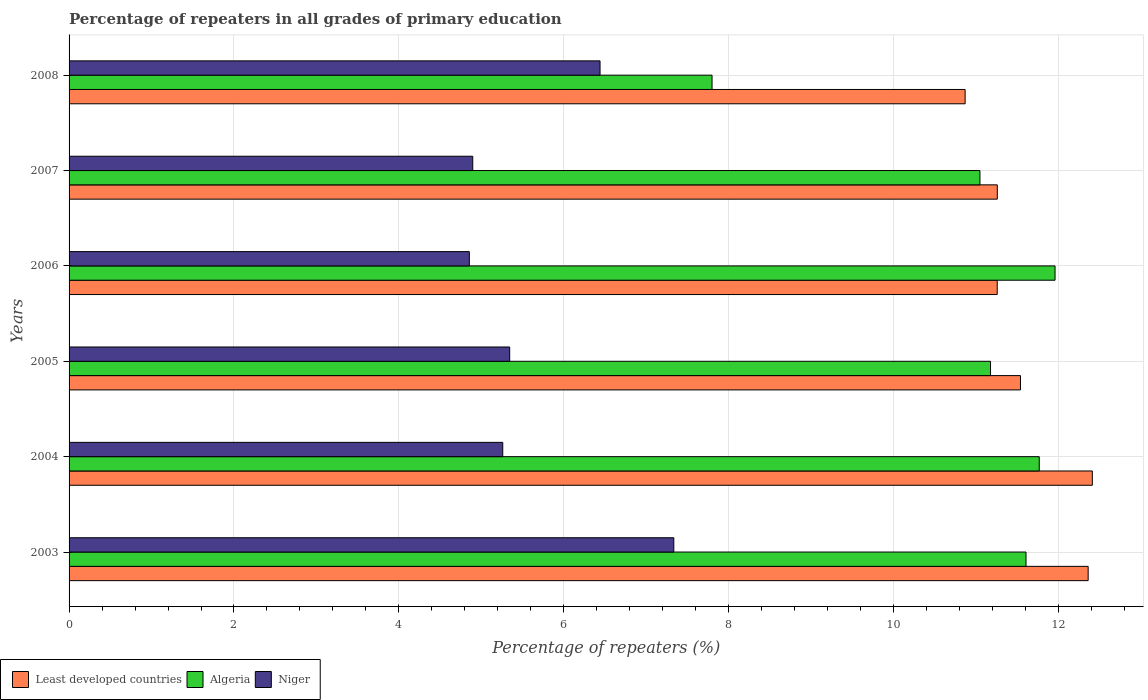How many different coloured bars are there?
Provide a succinct answer. 3. How many groups of bars are there?
Your response must be concise. 6. Are the number of bars per tick equal to the number of legend labels?
Offer a very short reply. Yes. Are the number of bars on each tick of the Y-axis equal?
Your answer should be compact. Yes. How many bars are there on the 1st tick from the bottom?
Make the answer very short. 3. In how many cases, is the number of bars for a given year not equal to the number of legend labels?
Keep it short and to the point. 0. What is the percentage of repeaters in Niger in 2007?
Offer a terse response. 4.9. Across all years, what is the maximum percentage of repeaters in Least developed countries?
Offer a very short reply. 12.41. Across all years, what is the minimum percentage of repeaters in Algeria?
Provide a short and direct response. 7.8. In which year was the percentage of repeaters in Niger maximum?
Offer a terse response. 2003. In which year was the percentage of repeaters in Niger minimum?
Make the answer very short. 2006. What is the total percentage of repeaters in Niger in the graph?
Your response must be concise. 34.13. What is the difference between the percentage of repeaters in Least developed countries in 2007 and that in 2008?
Ensure brevity in your answer.  0.39. What is the difference between the percentage of repeaters in Least developed countries in 2006 and the percentage of repeaters in Niger in 2007?
Provide a short and direct response. 6.36. What is the average percentage of repeaters in Niger per year?
Offer a very short reply. 5.69. In the year 2005, what is the difference between the percentage of repeaters in Least developed countries and percentage of repeaters in Algeria?
Ensure brevity in your answer.  0.36. What is the ratio of the percentage of repeaters in Least developed countries in 2004 to that in 2007?
Offer a very short reply. 1.1. Is the difference between the percentage of repeaters in Least developed countries in 2003 and 2008 greater than the difference between the percentage of repeaters in Algeria in 2003 and 2008?
Offer a terse response. No. What is the difference between the highest and the second highest percentage of repeaters in Least developed countries?
Your answer should be compact. 0.05. What is the difference between the highest and the lowest percentage of repeaters in Least developed countries?
Keep it short and to the point. 1.54. In how many years, is the percentage of repeaters in Least developed countries greater than the average percentage of repeaters in Least developed countries taken over all years?
Your answer should be compact. 2. What does the 2nd bar from the top in 2004 represents?
Give a very brief answer. Algeria. What does the 1st bar from the bottom in 2008 represents?
Give a very brief answer. Least developed countries. Is it the case that in every year, the sum of the percentage of repeaters in Least developed countries and percentage of repeaters in Niger is greater than the percentage of repeaters in Algeria?
Provide a short and direct response. Yes. How many bars are there?
Offer a terse response. 18. Are all the bars in the graph horizontal?
Offer a very short reply. Yes. How many years are there in the graph?
Your answer should be compact. 6. Are the values on the major ticks of X-axis written in scientific E-notation?
Offer a terse response. No. Does the graph contain any zero values?
Your answer should be very brief. No. How many legend labels are there?
Offer a very short reply. 3. What is the title of the graph?
Offer a very short reply. Percentage of repeaters in all grades of primary education. What is the label or title of the X-axis?
Offer a very short reply. Percentage of repeaters (%). What is the label or title of the Y-axis?
Ensure brevity in your answer.  Years. What is the Percentage of repeaters (%) in Least developed countries in 2003?
Offer a terse response. 12.36. What is the Percentage of repeaters (%) of Algeria in 2003?
Give a very brief answer. 11.61. What is the Percentage of repeaters (%) in Niger in 2003?
Your response must be concise. 7.33. What is the Percentage of repeaters (%) in Least developed countries in 2004?
Offer a very short reply. 12.41. What is the Percentage of repeaters (%) of Algeria in 2004?
Provide a short and direct response. 11.77. What is the Percentage of repeaters (%) of Niger in 2004?
Make the answer very short. 5.26. What is the Percentage of repeaters (%) of Least developed countries in 2005?
Provide a succinct answer. 11.54. What is the Percentage of repeaters (%) in Algeria in 2005?
Your answer should be compact. 11.18. What is the Percentage of repeaters (%) in Niger in 2005?
Provide a short and direct response. 5.34. What is the Percentage of repeaters (%) in Least developed countries in 2006?
Keep it short and to the point. 11.26. What is the Percentage of repeaters (%) of Algeria in 2006?
Provide a short and direct response. 11.96. What is the Percentage of repeaters (%) of Niger in 2006?
Your answer should be compact. 4.85. What is the Percentage of repeaters (%) in Least developed countries in 2007?
Provide a short and direct response. 11.26. What is the Percentage of repeaters (%) of Algeria in 2007?
Give a very brief answer. 11.05. What is the Percentage of repeaters (%) of Niger in 2007?
Provide a short and direct response. 4.9. What is the Percentage of repeaters (%) of Least developed countries in 2008?
Give a very brief answer. 10.87. What is the Percentage of repeaters (%) of Algeria in 2008?
Make the answer very short. 7.8. What is the Percentage of repeaters (%) of Niger in 2008?
Offer a terse response. 6.44. Across all years, what is the maximum Percentage of repeaters (%) of Least developed countries?
Your answer should be very brief. 12.41. Across all years, what is the maximum Percentage of repeaters (%) of Algeria?
Your answer should be compact. 11.96. Across all years, what is the maximum Percentage of repeaters (%) in Niger?
Provide a succinct answer. 7.33. Across all years, what is the minimum Percentage of repeaters (%) in Least developed countries?
Provide a short and direct response. 10.87. Across all years, what is the minimum Percentage of repeaters (%) in Algeria?
Provide a succinct answer. 7.8. Across all years, what is the minimum Percentage of repeaters (%) in Niger?
Provide a succinct answer. 4.85. What is the total Percentage of repeaters (%) of Least developed countries in the graph?
Your answer should be compact. 69.69. What is the total Percentage of repeaters (%) of Algeria in the graph?
Keep it short and to the point. 65.35. What is the total Percentage of repeaters (%) in Niger in the graph?
Your answer should be very brief. 34.13. What is the difference between the Percentage of repeaters (%) in Least developed countries in 2003 and that in 2004?
Provide a succinct answer. -0.05. What is the difference between the Percentage of repeaters (%) of Algeria in 2003 and that in 2004?
Provide a short and direct response. -0.16. What is the difference between the Percentage of repeaters (%) in Niger in 2003 and that in 2004?
Your answer should be very brief. 2.07. What is the difference between the Percentage of repeaters (%) in Least developed countries in 2003 and that in 2005?
Your response must be concise. 0.82. What is the difference between the Percentage of repeaters (%) in Algeria in 2003 and that in 2005?
Your answer should be compact. 0.43. What is the difference between the Percentage of repeaters (%) in Niger in 2003 and that in 2005?
Provide a short and direct response. 1.99. What is the difference between the Percentage of repeaters (%) in Least developed countries in 2003 and that in 2006?
Offer a terse response. 1.1. What is the difference between the Percentage of repeaters (%) of Algeria in 2003 and that in 2006?
Give a very brief answer. -0.35. What is the difference between the Percentage of repeaters (%) of Niger in 2003 and that in 2006?
Give a very brief answer. 2.48. What is the difference between the Percentage of repeaters (%) of Least developed countries in 2003 and that in 2007?
Provide a short and direct response. 1.1. What is the difference between the Percentage of repeaters (%) of Algeria in 2003 and that in 2007?
Your response must be concise. 0.56. What is the difference between the Percentage of repeaters (%) of Niger in 2003 and that in 2007?
Give a very brief answer. 2.44. What is the difference between the Percentage of repeaters (%) in Least developed countries in 2003 and that in 2008?
Offer a very short reply. 1.49. What is the difference between the Percentage of repeaters (%) in Algeria in 2003 and that in 2008?
Keep it short and to the point. 3.81. What is the difference between the Percentage of repeaters (%) in Niger in 2003 and that in 2008?
Ensure brevity in your answer.  0.89. What is the difference between the Percentage of repeaters (%) in Least developed countries in 2004 and that in 2005?
Your answer should be very brief. 0.87. What is the difference between the Percentage of repeaters (%) in Algeria in 2004 and that in 2005?
Your answer should be very brief. 0.59. What is the difference between the Percentage of repeaters (%) of Niger in 2004 and that in 2005?
Ensure brevity in your answer.  -0.08. What is the difference between the Percentage of repeaters (%) in Least developed countries in 2004 and that in 2006?
Offer a terse response. 1.15. What is the difference between the Percentage of repeaters (%) in Algeria in 2004 and that in 2006?
Make the answer very short. -0.19. What is the difference between the Percentage of repeaters (%) in Niger in 2004 and that in 2006?
Keep it short and to the point. 0.41. What is the difference between the Percentage of repeaters (%) in Least developed countries in 2004 and that in 2007?
Offer a very short reply. 1.15. What is the difference between the Percentage of repeaters (%) of Algeria in 2004 and that in 2007?
Ensure brevity in your answer.  0.72. What is the difference between the Percentage of repeaters (%) of Niger in 2004 and that in 2007?
Give a very brief answer. 0.36. What is the difference between the Percentage of repeaters (%) of Least developed countries in 2004 and that in 2008?
Keep it short and to the point. 1.54. What is the difference between the Percentage of repeaters (%) in Algeria in 2004 and that in 2008?
Ensure brevity in your answer.  3.97. What is the difference between the Percentage of repeaters (%) of Niger in 2004 and that in 2008?
Give a very brief answer. -1.18. What is the difference between the Percentage of repeaters (%) in Least developed countries in 2005 and that in 2006?
Offer a very short reply. 0.28. What is the difference between the Percentage of repeaters (%) of Algeria in 2005 and that in 2006?
Your answer should be compact. -0.78. What is the difference between the Percentage of repeaters (%) in Niger in 2005 and that in 2006?
Your answer should be very brief. 0.49. What is the difference between the Percentage of repeaters (%) in Least developed countries in 2005 and that in 2007?
Offer a terse response. 0.28. What is the difference between the Percentage of repeaters (%) in Algeria in 2005 and that in 2007?
Provide a short and direct response. 0.13. What is the difference between the Percentage of repeaters (%) in Niger in 2005 and that in 2007?
Keep it short and to the point. 0.45. What is the difference between the Percentage of repeaters (%) of Least developed countries in 2005 and that in 2008?
Your answer should be very brief. 0.67. What is the difference between the Percentage of repeaters (%) of Algeria in 2005 and that in 2008?
Keep it short and to the point. 3.38. What is the difference between the Percentage of repeaters (%) in Niger in 2005 and that in 2008?
Offer a terse response. -1.1. What is the difference between the Percentage of repeaters (%) in Least developed countries in 2006 and that in 2007?
Provide a succinct answer. -0. What is the difference between the Percentage of repeaters (%) in Algeria in 2006 and that in 2007?
Give a very brief answer. 0.91. What is the difference between the Percentage of repeaters (%) in Niger in 2006 and that in 2007?
Offer a very short reply. -0.04. What is the difference between the Percentage of repeaters (%) of Least developed countries in 2006 and that in 2008?
Make the answer very short. 0.39. What is the difference between the Percentage of repeaters (%) of Algeria in 2006 and that in 2008?
Offer a very short reply. 4.16. What is the difference between the Percentage of repeaters (%) in Niger in 2006 and that in 2008?
Make the answer very short. -1.59. What is the difference between the Percentage of repeaters (%) of Least developed countries in 2007 and that in 2008?
Keep it short and to the point. 0.39. What is the difference between the Percentage of repeaters (%) of Algeria in 2007 and that in 2008?
Provide a succinct answer. 3.25. What is the difference between the Percentage of repeaters (%) of Niger in 2007 and that in 2008?
Give a very brief answer. -1.54. What is the difference between the Percentage of repeaters (%) of Least developed countries in 2003 and the Percentage of repeaters (%) of Algeria in 2004?
Keep it short and to the point. 0.59. What is the difference between the Percentage of repeaters (%) in Least developed countries in 2003 and the Percentage of repeaters (%) in Niger in 2004?
Give a very brief answer. 7.1. What is the difference between the Percentage of repeaters (%) of Algeria in 2003 and the Percentage of repeaters (%) of Niger in 2004?
Your response must be concise. 6.35. What is the difference between the Percentage of repeaters (%) of Least developed countries in 2003 and the Percentage of repeaters (%) of Algeria in 2005?
Offer a very short reply. 1.18. What is the difference between the Percentage of repeaters (%) in Least developed countries in 2003 and the Percentage of repeaters (%) in Niger in 2005?
Your response must be concise. 7.02. What is the difference between the Percentage of repeaters (%) in Algeria in 2003 and the Percentage of repeaters (%) in Niger in 2005?
Keep it short and to the point. 6.26. What is the difference between the Percentage of repeaters (%) in Least developed countries in 2003 and the Percentage of repeaters (%) in Algeria in 2006?
Provide a short and direct response. 0.4. What is the difference between the Percentage of repeaters (%) in Least developed countries in 2003 and the Percentage of repeaters (%) in Niger in 2006?
Make the answer very short. 7.51. What is the difference between the Percentage of repeaters (%) in Algeria in 2003 and the Percentage of repeaters (%) in Niger in 2006?
Keep it short and to the point. 6.75. What is the difference between the Percentage of repeaters (%) in Least developed countries in 2003 and the Percentage of repeaters (%) in Algeria in 2007?
Provide a short and direct response. 1.31. What is the difference between the Percentage of repeaters (%) of Least developed countries in 2003 and the Percentage of repeaters (%) of Niger in 2007?
Your answer should be compact. 7.46. What is the difference between the Percentage of repeaters (%) in Algeria in 2003 and the Percentage of repeaters (%) in Niger in 2007?
Provide a succinct answer. 6.71. What is the difference between the Percentage of repeaters (%) of Least developed countries in 2003 and the Percentage of repeaters (%) of Algeria in 2008?
Provide a succinct answer. 4.56. What is the difference between the Percentage of repeaters (%) in Least developed countries in 2003 and the Percentage of repeaters (%) in Niger in 2008?
Offer a very short reply. 5.92. What is the difference between the Percentage of repeaters (%) in Algeria in 2003 and the Percentage of repeaters (%) in Niger in 2008?
Keep it short and to the point. 5.17. What is the difference between the Percentage of repeaters (%) of Least developed countries in 2004 and the Percentage of repeaters (%) of Algeria in 2005?
Provide a succinct answer. 1.23. What is the difference between the Percentage of repeaters (%) in Least developed countries in 2004 and the Percentage of repeaters (%) in Niger in 2005?
Your answer should be compact. 7.07. What is the difference between the Percentage of repeaters (%) in Algeria in 2004 and the Percentage of repeaters (%) in Niger in 2005?
Provide a succinct answer. 6.42. What is the difference between the Percentage of repeaters (%) in Least developed countries in 2004 and the Percentage of repeaters (%) in Algeria in 2006?
Keep it short and to the point. 0.45. What is the difference between the Percentage of repeaters (%) in Least developed countries in 2004 and the Percentage of repeaters (%) in Niger in 2006?
Give a very brief answer. 7.56. What is the difference between the Percentage of repeaters (%) of Algeria in 2004 and the Percentage of repeaters (%) of Niger in 2006?
Your answer should be compact. 6.91. What is the difference between the Percentage of repeaters (%) in Least developed countries in 2004 and the Percentage of repeaters (%) in Algeria in 2007?
Make the answer very short. 1.36. What is the difference between the Percentage of repeaters (%) in Least developed countries in 2004 and the Percentage of repeaters (%) in Niger in 2007?
Provide a succinct answer. 7.51. What is the difference between the Percentage of repeaters (%) in Algeria in 2004 and the Percentage of repeaters (%) in Niger in 2007?
Provide a succinct answer. 6.87. What is the difference between the Percentage of repeaters (%) in Least developed countries in 2004 and the Percentage of repeaters (%) in Algeria in 2008?
Your response must be concise. 4.61. What is the difference between the Percentage of repeaters (%) of Least developed countries in 2004 and the Percentage of repeaters (%) of Niger in 2008?
Keep it short and to the point. 5.97. What is the difference between the Percentage of repeaters (%) in Algeria in 2004 and the Percentage of repeaters (%) in Niger in 2008?
Provide a short and direct response. 5.33. What is the difference between the Percentage of repeaters (%) of Least developed countries in 2005 and the Percentage of repeaters (%) of Algeria in 2006?
Your answer should be compact. -0.42. What is the difference between the Percentage of repeaters (%) of Least developed countries in 2005 and the Percentage of repeaters (%) of Niger in 2006?
Provide a succinct answer. 6.68. What is the difference between the Percentage of repeaters (%) of Algeria in 2005 and the Percentage of repeaters (%) of Niger in 2006?
Give a very brief answer. 6.32. What is the difference between the Percentage of repeaters (%) in Least developed countries in 2005 and the Percentage of repeaters (%) in Algeria in 2007?
Give a very brief answer. 0.49. What is the difference between the Percentage of repeaters (%) of Least developed countries in 2005 and the Percentage of repeaters (%) of Niger in 2007?
Offer a terse response. 6.64. What is the difference between the Percentage of repeaters (%) in Algeria in 2005 and the Percentage of repeaters (%) in Niger in 2007?
Provide a succinct answer. 6.28. What is the difference between the Percentage of repeaters (%) of Least developed countries in 2005 and the Percentage of repeaters (%) of Algeria in 2008?
Your response must be concise. 3.74. What is the difference between the Percentage of repeaters (%) in Least developed countries in 2005 and the Percentage of repeaters (%) in Niger in 2008?
Your response must be concise. 5.1. What is the difference between the Percentage of repeaters (%) in Algeria in 2005 and the Percentage of repeaters (%) in Niger in 2008?
Your answer should be compact. 4.74. What is the difference between the Percentage of repeaters (%) of Least developed countries in 2006 and the Percentage of repeaters (%) of Algeria in 2007?
Your response must be concise. 0.21. What is the difference between the Percentage of repeaters (%) in Least developed countries in 2006 and the Percentage of repeaters (%) in Niger in 2007?
Ensure brevity in your answer.  6.36. What is the difference between the Percentage of repeaters (%) in Algeria in 2006 and the Percentage of repeaters (%) in Niger in 2007?
Provide a succinct answer. 7.06. What is the difference between the Percentage of repeaters (%) in Least developed countries in 2006 and the Percentage of repeaters (%) in Algeria in 2008?
Ensure brevity in your answer.  3.46. What is the difference between the Percentage of repeaters (%) in Least developed countries in 2006 and the Percentage of repeaters (%) in Niger in 2008?
Offer a terse response. 4.82. What is the difference between the Percentage of repeaters (%) of Algeria in 2006 and the Percentage of repeaters (%) of Niger in 2008?
Provide a short and direct response. 5.52. What is the difference between the Percentage of repeaters (%) of Least developed countries in 2007 and the Percentage of repeaters (%) of Algeria in 2008?
Keep it short and to the point. 3.46. What is the difference between the Percentage of repeaters (%) of Least developed countries in 2007 and the Percentage of repeaters (%) of Niger in 2008?
Your answer should be compact. 4.82. What is the difference between the Percentage of repeaters (%) in Algeria in 2007 and the Percentage of repeaters (%) in Niger in 2008?
Offer a very short reply. 4.61. What is the average Percentage of repeaters (%) in Least developed countries per year?
Give a very brief answer. 11.62. What is the average Percentage of repeaters (%) of Algeria per year?
Make the answer very short. 10.89. What is the average Percentage of repeaters (%) of Niger per year?
Offer a very short reply. 5.69. In the year 2003, what is the difference between the Percentage of repeaters (%) in Least developed countries and Percentage of repeaters (%) in Algeria?
Give a very brief answer. 0.75. In the year 2003, what is the difference between the Percentage of repeaters (%) in Least developed countries and Percentage of repeaters (%) in Niger?
Your response must be concise. 5.03. In the year 2003, what is the difference between the Percentage of repeaters (%) in Algeria and Percentage of repeaters (%) in Niger?
Your answer should be compact. 4.27. In the year 2004, what is the difference between the Percentage of repeaters (%) of Least developed countries and Percentage of repeaters (%) of Algeria?
Offer a very short reply. 0.64. In the year 2004, what is the difference between the Percentage of repeaters (%) in Least developed countries and Percentage of repeaters (%) in Niger?
Your answer should be very brief. 7.15. In the year 2004, what is the difference between the Percentage of repeaters (%) in Algeria and Percentage of repeaters (%) in Niger?
Provide a succinct answer. 6.51. In the year 2005, what is the difference between the Percentage of repeaters (%) of Least developed countries and Percentage of repeaters (%) of Algeria?
Make the answer very short. 0.36. In the year 2005, what is the difference between the Percentage of repeaters (%) in Least developed countries and Percentage of repeaters (%) in Niger?
Offer a very short reply. 6.2. In the year 2005, what is the difference between the Percentage of repeaters (%) of Algeria and Percentage of repeaters (%) of Niger?
Offer a very short reply. 5.83. In the year 2006, what is the difference between the Percentage of repeaters (%) in Least developed countries and Percentage of repeaters (%) in Algeria?
Offer a very short reply. -0.7. In the year 2006, what is the difference between the Percentage of repeaters (%) in Least developed countries and Percentage of repeaters (%) in Niger?
Keep it short and to the point. 6.4. In the year 2006, what is the difference between the Percentage of repeaters (%) in Algeria and Percentage of repeaters (%) in Niger?
Your answer should be very brief. 7.1. In the year 2007, what is the difference between the Percentage of repeaters (%) in Least developed countries and Percentage of repeaters (%) in Algeria?
Make the answer very short. 0.21. In the year 2007, what is the difference between the Percentage of repeaters (%) in Least developed countries and Percentage of repeaters (%) in Niger?
Your response must be concise. 6.36. In the year 2007, what is the difference between the Percentage of repeaters (%) in Algeria and Percentage of repeaters (%) in Niger?
Offer a very short reply. 6.15. In the year 2008, what is the difference between the Percentage of repeaters (%) in Least developed countries and Percentage of repeaters (%) in Algeria?
Your response must be concise. 3.07. In the year 2008, what is the difference between the Percentage of repeaters (%) in Least developed countries and Percentage of repeaters (%) in Niger?
Your response must be concise. 4.43. In the year 2008, what is the difference between the Percentage of repeaters (%) of Algeria and Percentage of repeaters (%) of Niger?
Your answer should be very brief. 1.36. What is the ratio of the Percentage of repeaters (%) of Least developed countries in 2003 to that in 2004?
Provide a short and direct response. 1. What is the ratio of the Percentage of repeaters (%) of Algeria in 2003 to that in 2004?
Provide a short and direct response. 0.99. What is the ratio of the Percentage of repeaters (%) of Niger in 2003 to that in 2004?
Provide a succinct answer. 1.39. What is the ratio of the Percentage of repeaters (%) of Least developed countries in 2003 to that in 2005?
Your answer should be compact. 1.07. What is the ratio of the Percentage of repeaters (%) in Niger in 2003 to that in 2005?
Your answer should be compact. 1.37. What is the ratio of the Percentage of repeaters (%) of Least developed countries in 2003 to that in 2006?
Offer a terse response. 1.1. What is the ratio of the Percentage of repeaters (%) of Algeria in 2003 to that in 2006?
Offer a very short reply. 0.97. What is the ratio of the Percentage of repeaters (%) of Niger in 2003 to that in 2006?
Your answer should be compact. 1.51. What is the ratio of the Percentage of repeaters (%) in Least developed countries in 2003 to that in 2007?
Your answer should be compact. 1.1. What is the ratio of the Percentage of repeaters (%) in Algeria in 2003 to that in 2007?
Your response must be concise. 1.05. What is the ratio of the Percentage of repeaters (%) of Niger in 2003 to that in 2007?
Provide a short and direct response. 1.5. What is the ratio of the Percentage of repeaters (%) of Least developed countries in 2003 to that in 2008?
Make the answer very short. 1.14. What is the ratio of the Percentage of repeaters (%) in Algeria in 2003 to that in 2008?
Your answer should be compact. 1.49. What is the ratio of the Percentage of repeaters (%) of Niger in 2003 to that in 2008?
Give a very brief answer. 1.14. What is the ratio of the Percentage of repeaters (%) of Least developed countries in 2004 to that in 2005?
Give a very brief answer. 1.08. What is the ratio of the Percentage of repeaters (%) of Algeria in 2004 to that in 2005?
Make the answer very short. 1.05. What is the ratio of the Percentage of repeaters (%) in Niger in 2004 to that in 2005?
Provide a succinct answer. 0.98. What is the ratio of the Percentage of repeaters (%) in Least developed countries in 2004 to that in 2006?
Provide a succinct answer. 1.1. What is the ratio of the Percentage of repeaters (%) of Algeria in 2004 to that in 2006?
Keep it short and to the point. 0.98. What is the ratio of the Percentage of repeaters (%) of Niger in 2004 to that in 2006?
Provide a short and direct response. 1.08. What is the ratio of the Percentage of repeaters (%) of Least developed countries in 2004 to that in 2007?
Keep it short and to the point. 1.1. What is the ratio of the Percentage of repeaters (%) of Algeria in 2004 to that in 2007?
Your answer should be compact. 1.07. What is the ratio of the Percentage of repeaters (%) of Niger in 2004 to that in 2007?
Your response must be concise. 1.07. What is the ratio of the Percentage of repeaters (%) in Least developed countries in 2004 to that in 2008?
Give a very brief answer. 1.14. What is the ratio of the Percentage of repeaters (%) in Algeria in 2004 to that in 2008?
Your answer should be very brief. 1.51. What is the ratio of the Percentage of repeaters (%) of Niger in 2004 to that in 2008?
Your answer should be compact. 0.82. What is the ratio of the Percentage of repeaters (%) of Least developed countries in 2005 to that in 2006?
Provide a short and direct response. 1.03. What is the ratio of the Percentage of repeaters (%) of Algeria in 2005 to that in 2006?
Provide a short and direct response. 0.93. What is the ratio of the Percentage of repeaters (%) of Niger in 2005 to that in 2006?
Offer a terse response. 1.1. What is the ratio of the Percentage of repeaters (%) in Least developed countries in 2005 to that in 2007?
Your answer should be very brief. 1.02. What is the ratio of the Percentage of repeaters (%) of Algeria in 2005 to that in 2007?
Offer a terse response. 1.01. What is the ratio of the Percentage of repeaters (%) of Niger in 2005 to that in 2007?
Keep it short and to the point. 1.09. What is the ratio of the Percentage of repeaters (%) of Least developed countries in 2005 to that in 2008?
Ensure brevity in your answer.  1.06. What is the ratio of the Percentage of repeaters (%) of Algeria in 2005 to that in 2008?
Your answer should be very brief. 1.43. What is the ratio of the Percentage of repeaters (%) of Niger in 2005 to that in 2008?
Make the answer very short. 0.83. What is the ratio of the Percentage of repeaters (%) in Least developed countries in 2006 to that in 2007?
Your answer should be compact. 1. What is the ratio of the Percentage of repeaters (%) of Algeria in 2006 to that in 2007?
Offer a terse response. 1.08. What is the ratio of the Percentage of repeaters (%) of Niger in 2006 to that in 2007?
Your answer should be very brief. 0.99. What is the ratio of the Percentage of repeaters (%) of Least developed countries in 2006 to that in 2008?
Make the answer very short. 1.04. What is the ratio of the Percentage of repeaters (%) of Algeria in 2006 to that in 2008?
Your answer should be compact. 1.53. What is the ratio of the Percentage of repeaters (%) of Niger in 2006 to that in 2008?
Offer a very short reply. 0.75. What is the ratio of the Percentage of repeaters (%) in Least developed countries in 2007 to that in 2008?
Your answer should be very brief. 1.04. What is the ratio of the Percentage of repeaters (%) in Algeria in 2007 to that in 2008?
Ensure brevity in your answer.  1.42. What is the ratio of the Percentage of repeaters (%) in Niger in 2007 to that in 2008?
Provide a succinct answer. 0.76. What is the difference between the highest and the second highest Percentage of repeaters (%) of Least developed countries?
Provide a short and direct response. 0.05. What is the difference between the highest and the second highest Percentage of repeaters (%) in Algeria?
Your answer should be compact. 0.19. What is the difference between the highest and the second highest Percentage of repeaters (%) in Niger?
Offer a terse response. 0.89. What is the difference between the highest and the lowest Percentage of repeaters (%) of Least developed countries?
Ensure brevity in your answer.  1.54. What is the difference between the highest and the lowest Percentage of repeaters (%) of Algeria?
Offer a terse response. 4.16. What is the difference between the highest and the lowest Percentage of repeaters (%) in Niger?
Provide a succinct answer. 2.48. 